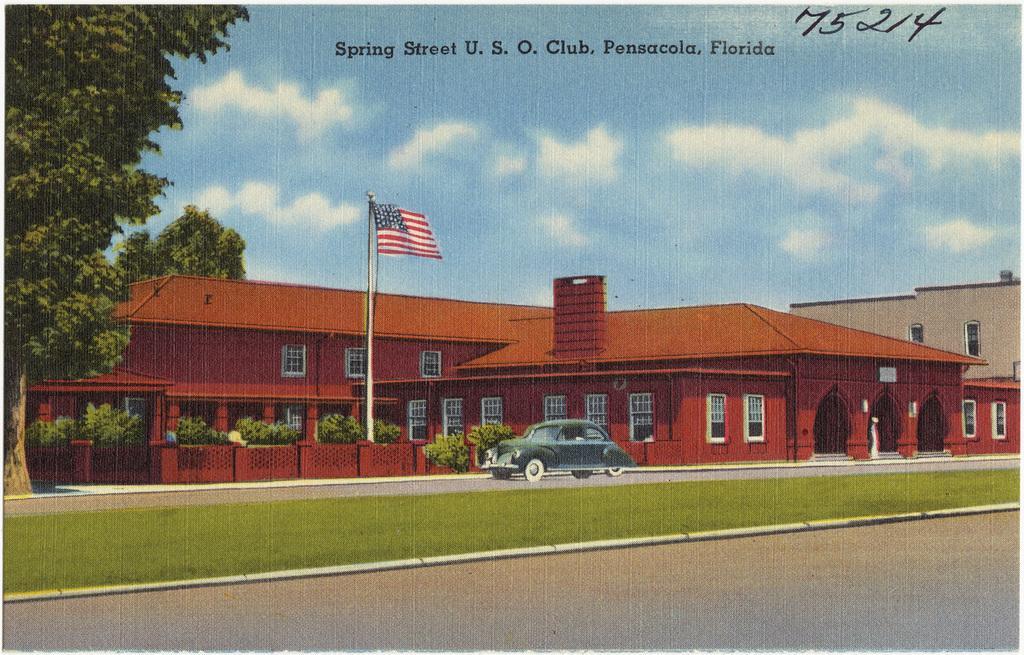Can you describe this image briefly? At the bottom of the picture, we see the road and the grass. Beside that, we see a car is moving on the road. Beside that, we see a building in brown color. In the middle of the picture, we see a flag pole and a flag in blue, white and red color. Behind that, we see the plants. On the left side, we see the trees. At the top, we see the sky and the clouds. This picture might be a poster or it might be a painting. 